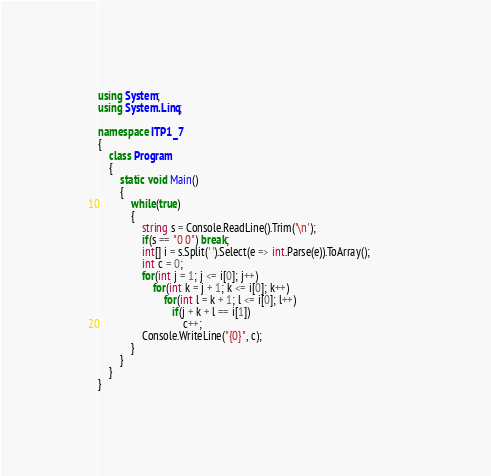<code> <loc_0><loc_0><loc_500><loc_500><_C#_>using System;
using System.Linq;

namespace ITP1_7
{
    class Program
    {
        static void Main()
        {
            while(true)
            {
                string s = Console.ReadLine().Trim('\n');
                if(s == "0 0") break;
                int[] i = s.Split(' ').Select(e => int.Parse(e)).ToArray();            
                int c = 0;
                for(int j = 1; j <= i[0]; j++)
                    for(int k = j + 1; k <= i[0]; k++)
                        for(int l = k + 1; l <= i[0]; l++)
                           if(j + k + l == i[1])
                               c++;              
                Console.WriteLine("{0}", c);
            }
        }
    }
}</code> 